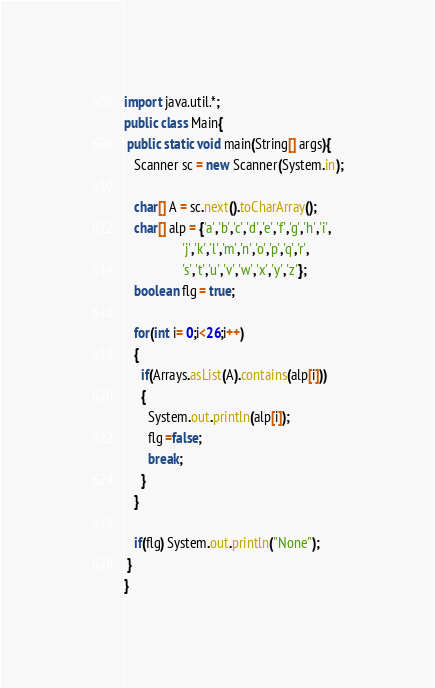<code> <loc_0><loc_0><loc_500><loc_500><_Java_>import java.util.*;
public class Main{
 public static void main(String[] args){
   Scanner sc = new Scanner(System.in);
 
   char[] A = sc.next().toCharArray();   
   char[] alp = {'a','b','c','d','e','f','g','h','i',
                 'j','k','l','m','n','o','p','q','r',
                 's','t','u','v','w','x','y','z'};
   boolean flg = true;
 
   for(int i= 0;i<26;i++)
   {
     if(Arrays.asList(A).contains(alp[i]))
     {
       System.out.println(alp[i]);
       flg =false;
       break;
     }
   }
 
   if(flg) System.out.println("None");
 }
}</code> 